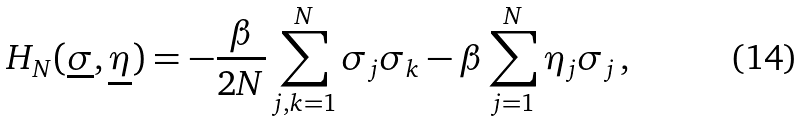<formula> <loc_0><loc_0><loc_500><loc_500>H _ { N } ( \underline { \sigma } , \underline { \eta } ) = - \frac { \beta } { 2 N } \sum _ { j , k = 1 } ^ { N } \sigma _ { j } \sigma _ { k } - \beta \sum _ { j = 1 } ^ { N } \eta _ { j } \sigma _ { j } \, ,</formula> 